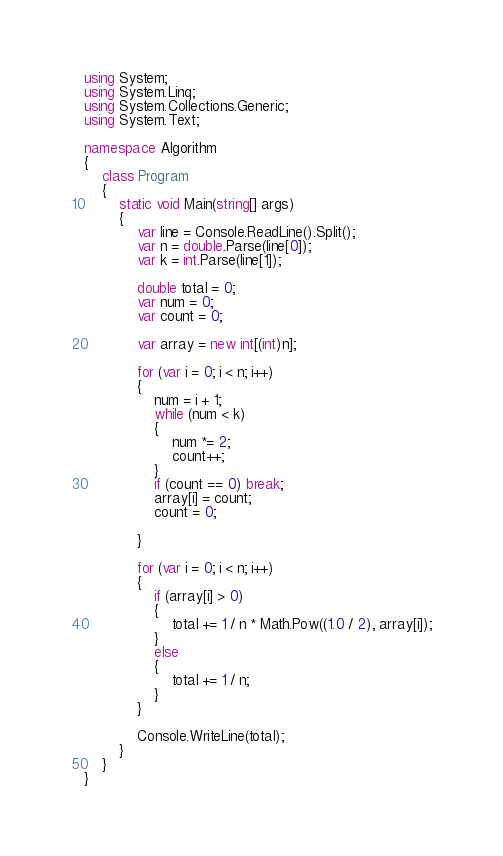<code> <loc_0><loc_0><loc_500><loc_500><_C#_>using System;
using System.Linq;
using System.Collections.Generic;
using System.Text;

namespace Algorithm
{
    class Program
    {
        static void Main(string[] args)
        {
            var line = Console.ReadLine().Split();
            var n = double.Parse(line[0]);
            var k = int.Parse(line[1]);

            double total = 0;
            var num = 0;
            var count = 0;

            var array = new int[(int)n];

            for (var i = 0; i < n; i++)
            {
                num = i + 1;
                while (num < k)
                {
                    num *= 2;
                    count++;
                }
                if (count == 0) break;
                array[i] = count;
                count = 0;

            }

            for (var i = 0; i < n; i++)
            {
                if (array[i] > 0)
                {
                    total += 1 / n * Math.Pow((1.0 / 2), array[i]);
                }
                else
                {
                    total += 1 / n;
                }
            }

            Console.WriteLine(total);
        }
    }
}
</code> 